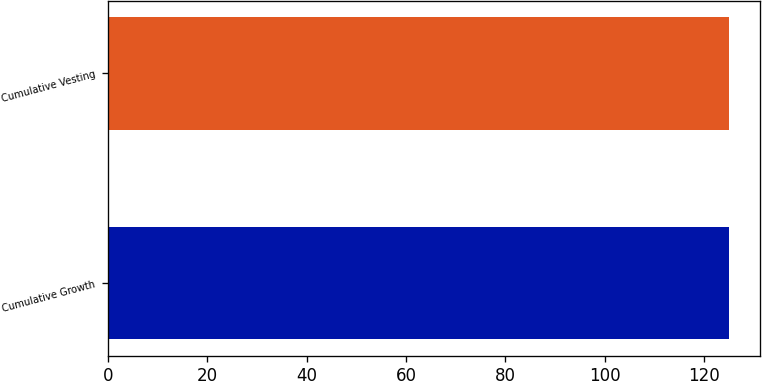<chart> <loc_0><loc_0><loc_500><loc_500><bar_chart><fcel>Cumulative Growth<fcel>Cumulative Vesting<nl><fcel>125<fcel>125.1<nl></chart> 